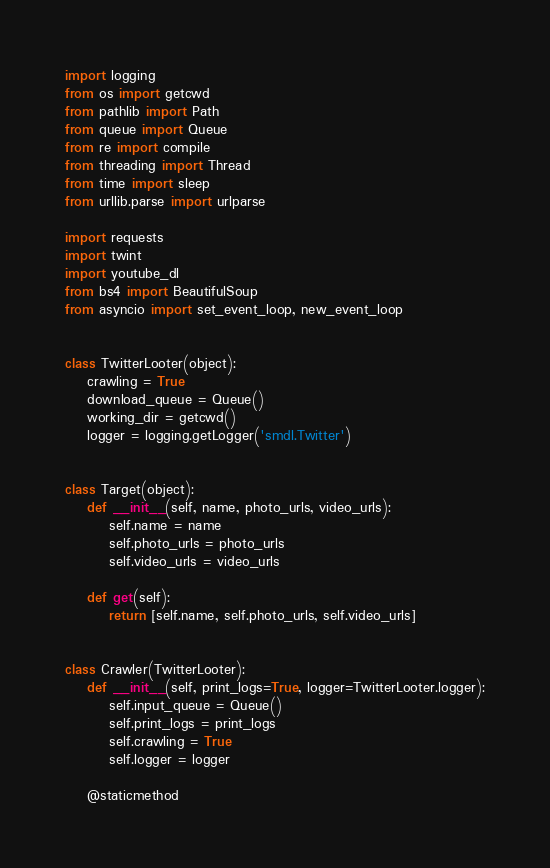<code> <loc_0><loc_0><loc_500><loc_500><_Python_>import logging
from os import getcwd
from pathlib import Path
from queue import Queue
from re import compile
from threading import Thread
from time import sleep
from urllib.parse import urlparse

import requests
import twint
import youtube_dl
from bs4 import BeautifulSoup
from asyncio import set_event_loop, new_event_loop


class TwitterLooter(object):
    crawling = True
    download_queue = Queue()
    working_dir = getcwd()
    logger = logging.getLogger('smdl.Twitter')


class Target(object):
    def __init__(self, name, photo_urls, video_urls):
        self.name = name
        self.photo_urls = photo_urls
        self.video_urls = video_urls

    def get(self):
        return [self.name, self.photo_urls, self.video_urls]


class Crawler(TwitterLooter):
    def __init__(self, print_logs=True, logger=TwitterLooter.logger):
        self.input_queue = Queue()
        self.print_logs = print_logs
        self.crawling = True
        self.logger = logger

    @staticmethod</code> 